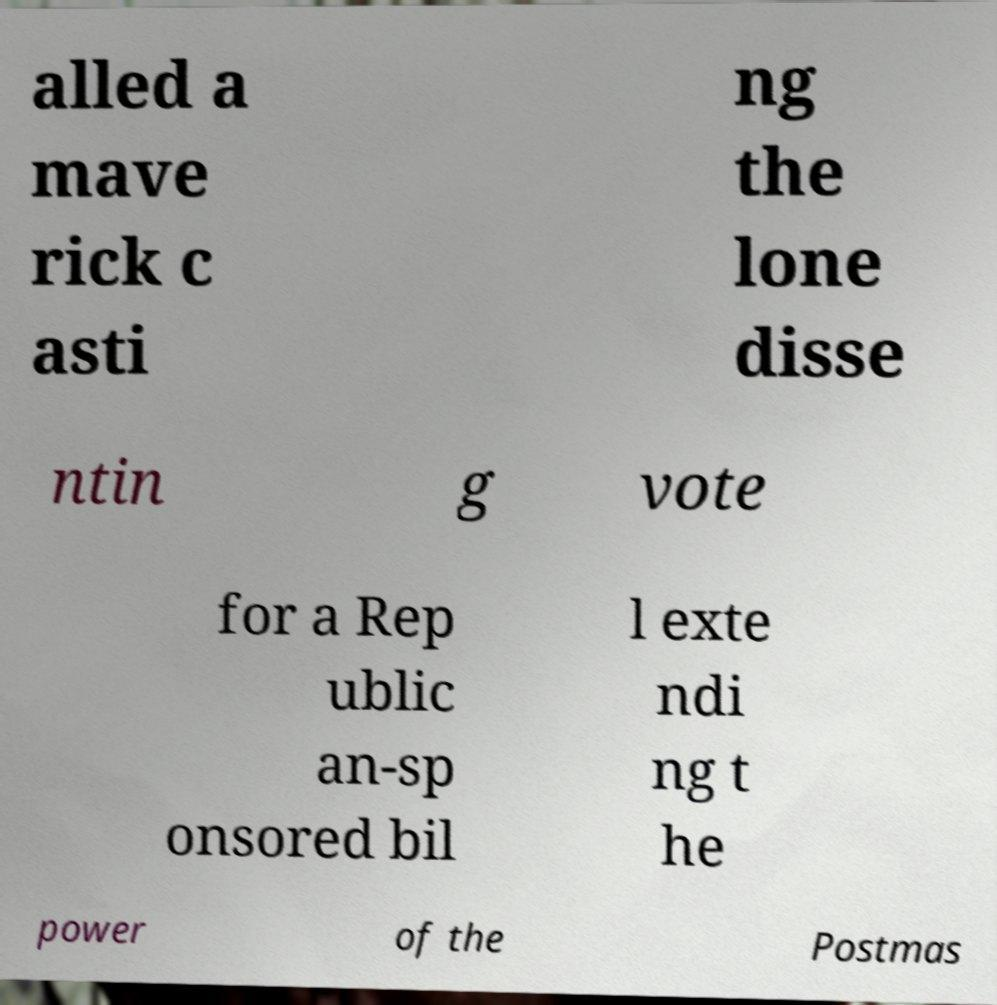I need the written content from this picture converted into text. Can you do that? alled a mave rick c asti ng the lone disse ntin g vote for a Rep ublic an-sp onsored bil l exte ndi ng t he power of the Postmas 